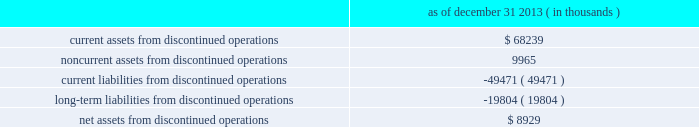Dish network corporation notes to consolidated financial statements - continued recorded as a decrease in 201cincome tax ( provision ) benefit , net 201d on our consolidated statements of operations and comprehensive income ( loss ) for the year ended december 31 , 2013 .
10 .
Discontinued operations as of december 31 , 2013 , blockbuster had ceased material operations .
The results of blockbuster are presented for all periods as discontinued operations in our consolidated financial statements .
During the years ended december 31 , 2013 and 2012 , the revenue from our discontinued operations was $ 503 million and $ 1.085 billion , respectively .
201cincome ( loss ) from discontinued operations , before income taxes 201d for the same periods was a loss of $ 54 million and $ 62 million , respectively .
In addition , 201cincome ( loss ) from discontinued operations , net of tax 201d for the same periods was a loss of $ 47 million and $ 37 million , respectively .
As of december 31 , 2013 , the net assets from our discontinued operations consisted of the following : december 31 , 2013 ( in thousands ) .
Blockbuster - domestic since the blockbuster acquisition , we continually evaluated the impact of certain factors , including , among other things , competitive pressures , the ability of significantly fewer company-owned domestic retail stores to continue to support corporate administrative costs , and other issues impacting the store-level financial performance of our company-owned domestic retail stores .
These factors , among others , previously led us to close a significant number of company-owned domestic retail stores during 2012 and 2013 .
On november 6 , 2013 , we announced that blockbuster would close all of its remaining company-owned domestic retail stores and discontinue the blockbuster by-mail dvd service .
As of december 31 , 2013 , blockbuster had ceased material operations .
Blockbuster 2013 mexico during the third quarter 2013 , we determined that our blockbuster operations in mexico ( 201cblockbuster mexico 201d ) were 201cheld for sale . 201d as a result , we recorded pre-tax impairment charges of $ 19 million related to exiting the business , which was recorded in 201cincome ( loss ) from discontinued operations , net of tax 201d on our consolidated statements of operations and comprehensive income ( loss ) for the year ended december 31 , 2013 .
On january 14 , 2014 , we completed the sale of blockbuster mexico .
Blockbuster uk administration on january 16 , 2013 , blockbuster entertainment limited and blockbuster gb limited , our blockbuster operating subsidiaries in the united kingdom , entered into administration proceedings in the united kingdom ( the 201cadministration 201d ) .
As a result of the administration , we wrote down the assets of all our blockbuster uk subsidiaries to their estimated net realizable value on our consolidated balance sheets as of december 31 , 2012 .
In total , we recorded charges of approximately $ 46 million on a pre-tax basis related to the administration , which was recorded in 201cincome ( loss ) from discontinued operations , net of tax 201d on our consolidated statements of operations and comprehensive income ( loss ) for the year ended december 31 , 2012. .
What is the tax expense related to discontinued operations in 2012? 
Computations: (62 - 37)
Answer: 25.0. 